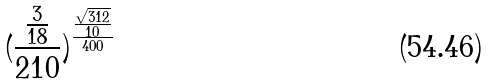Convert formula to latex. <formula><loc_0><loc_0><loc_500><loc_500>( \frac { \frac { 3 } { 1 8 } } { 2 1 0 } ) ^ { \frac { \frac { \sqrt { 3 1 2 } } { 1 0 } } { 4 0 0 } }</formula> 